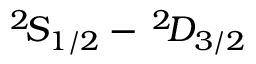<formula> <loc_0><loc_0><loc_500><loc_500>^ { 2 } \, S _ { 1 / 2 } - \, ^ { 2 } \, D _ { 3 / 2 }</formula> 